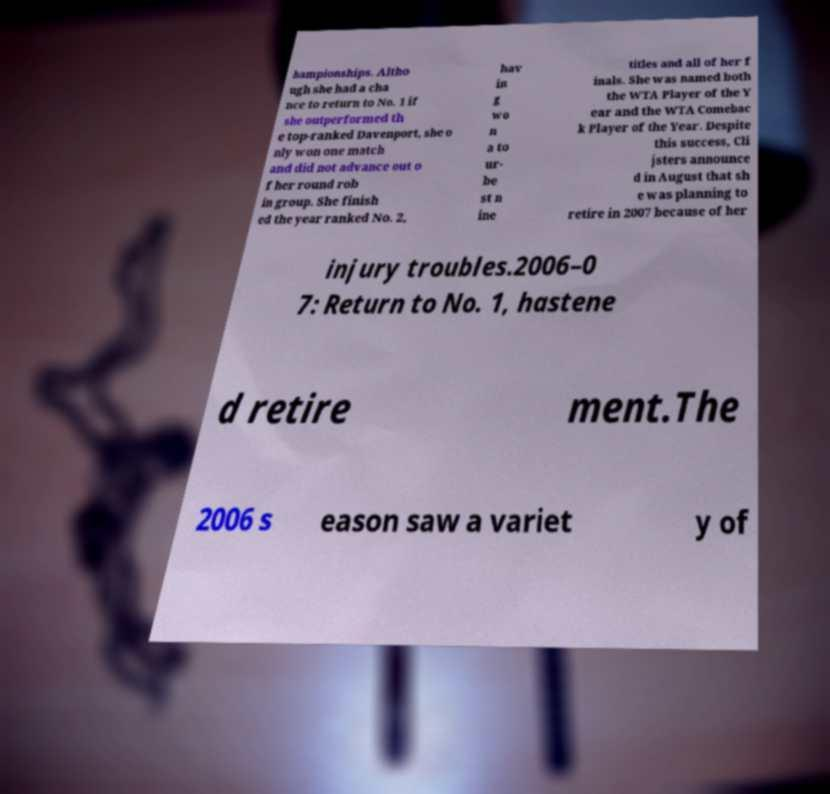Please read and relay the text visible in this image. What does it say? hampionships. Altho ugh she had a cha nce to return to No. 1 if she outperformed th e top-ranked Davenport, she o nly won one match and did not advance out o f her round rob in group. She finish ed the year ranked No. 2, hav in g wo n a to ur- be st n ine titles and all of her f inals. She was named both the WTA Player of the Y ear and the WTA Comebac k Player of the Year. Despite this success, Cli jsters announce d in August that sh e was planning to retire in 2007 because of her injury troubles.2006–0 7: Return to No. 1, hastene d retire ment.The 2006 s eason saw a variet y of 